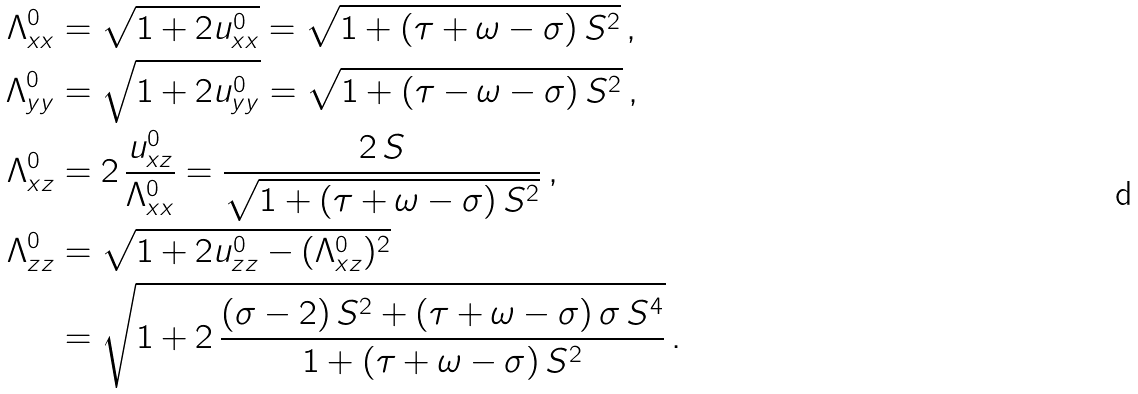<formula> <loc_0><loc_0><loc_500><loc_500>\Lambda _ { x x } ^ { 0 } & = \sqrt { 1 + 2 u _ { x x } ^ { 0 } } = \sqrt { 1 + ( \tau + \omega - \sigma ) \, S ^ { 2 } } \, , \\ \Lambda _ { y y } ^ { 0 } & = \sqrt { 1 + 2 u _ { y y } ^ { 0 } } = \sqrt { 1 + ( \tau - \omega - \sigma ) \, S ^ { 2 } } \, , \\ \Lambda _ { x z } ^ { 0 } & = 2 \, \frac { u _ { x z } ^ { 0 } } { \Lambda _ { x x } ^ { 0 } } = \frac { 2 \, S } { \sqrt { 1 + ( \tau + \omega - \sigma ) \, S ^ { 2 } } } \, , \\ \Lambda _ { z z } ^ { 0 } & = \sqrt { 1 + 2 u _ { z z } ^ { 0 } - ( \Lambda _ { x z } ^ { 0 } ) ^ { 2 } } \\ & = \sqrt { 1 + 2 \, \frac { ( \sigma - 2 ) \, S ^ { 2 } + ( \tau + \omega - \sigma ) \, \sigma \, S ^ { 4 } } { 1 + ( \tau + \omega - \sigma ) \, S ^ { 2 } } } \, .</formula> 